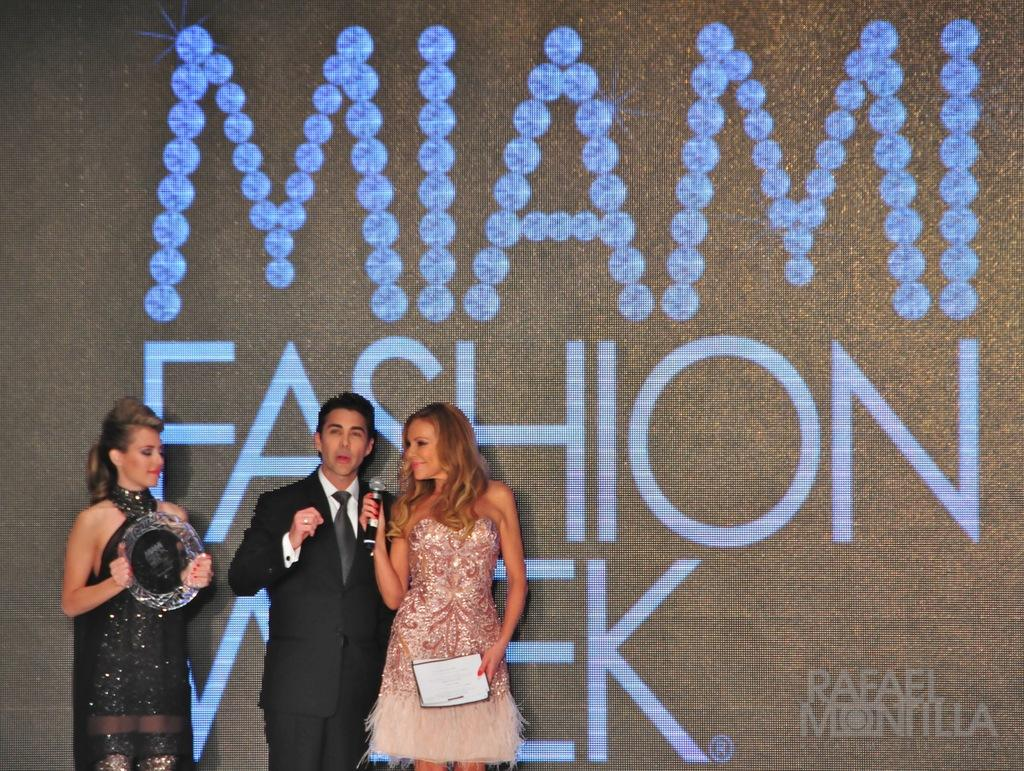How many people are in the image? There are three persons standing in the image. What is the person in front wearing? The person in front is wearing a black blazer, a white shirt, and a black tie. What can be seen in the background of the image? There is a screen visible in the background of the image. What year is the person in front offering to travel to? There is no indication in the image that the person in front is offering to travel to any specific year. 